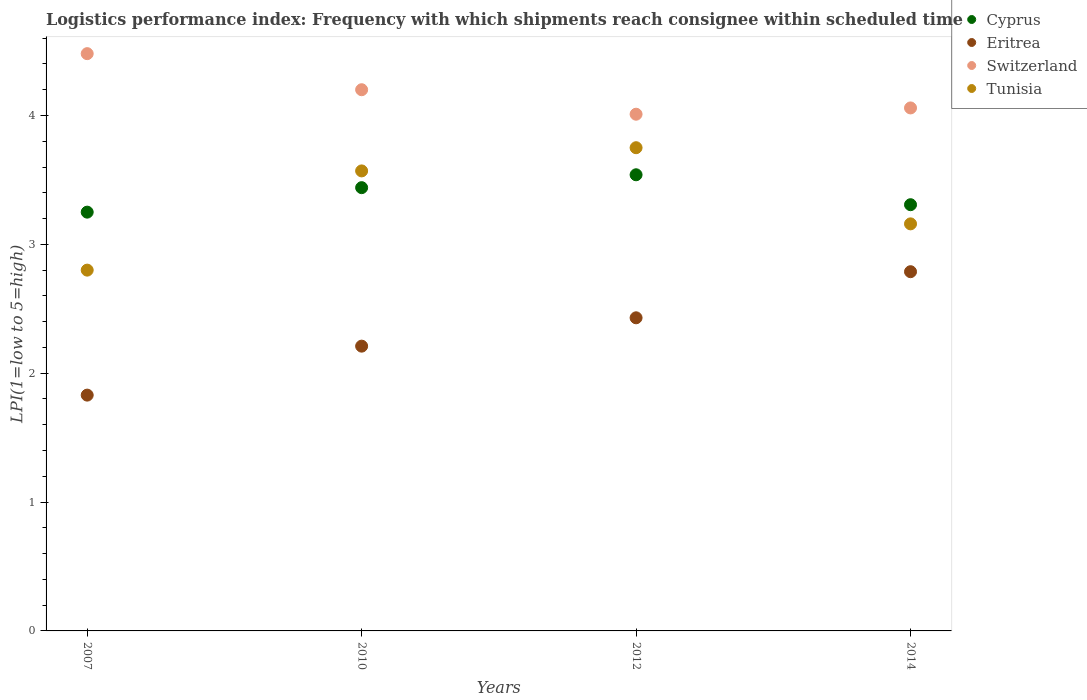How many different coloured dotlines are there?
Provide a short and direct response. 4. Is the number of dotlines equal to the number of legend labels?
Keep it short and to the point. Yes. What is the logistics performance index in Cyprus in 2012?
Your answer should be very brief. 3.54. Across all years, what is the maximum logistics performance index in Cyprus?
Make the answer very short. 3.54. Across all years, what is the minimum logistics performance index in Cyprus?
Ensure brevity in your answer.  3.25. What is the total logistics performance index in Cyprus in the graph?
Your answer should be compact. 13.54. What is the difference between the logistics performance index in Cyprus in 2012 and that in 2014?
Provide a short and direct response. 0.23. What is the difference between the logistics performance index in Cyprus in 2012 and the logistics performance index in Tunisia in 2007?
Your answer should be compact. 0.74. What is the average logistics performance index in Cyprus per year?
Your answer should be compact. 3.38. In the year 2014, what is the difference between the logistics performance index in Switzerland and logistics performance index in Eritrea?
Give a very brief answer. 1.27. What is the ratio of the logistics performance index in Tunisia in 2010 to that in 2014?
Offer a very short reply. 1.13. What is the difference between the highest and the second highest logistics performance index in Cyprus?
Offer a terse response. 0.1. What is the difference between the highest and the lowest logistics performance index in Cyprus?
Your answer should be very brief. 0.29. In how many years, is the logistics performance index in Tunisia greater than the average logistics performance index in Tunisia taken over all years?
Offer a very short reply. 2. Is the sum of the logistics performance index in Cyprus in 2007 and 2012 greater than the maximum logistics performance index in Eritrea across all years?
Your answer should be compact. Yes. Is it the case that in every year, the sum of the logistics performance index in Switzerland and logistics performance index in Tunisia  is greater than the sum of logistics performance index in Eritrea and logistics performance index in Cyprus?
Ensure brevity in your answer.  Yes. How many years are there in the graph?
Offer a terse response. 4. What is the difference between two consecutive major ticks on the Y-axis?
Your answer should be very brief. 1. Does the graph contain any zero values?
Make the answer very short. No. How many legend labels are there?
Provide a succinct answer. 4. What is the title of the graph?
Your answer should be compact. Logistics performance index: Frequency with which shipments reach consignee within scheduled time. Does "Low & middle income" appear as one of the legend labels in the graph?
Your response must be concise. No. What is the label or title of the X-axis?
Keep it short and to the point. Years. What is the label or title of the Y-axis?
Offer a terse response. LPI(1=low to 5=high). What is the LPI(1=low to 5=high) in Eritrea in 2007?
Offer a terse response. 1.83. What is the LPI(1=low to 5=high) of Switzerland in 2007?
Provide a succinct answer. 4.48. What is the LPI(1=low to 5=high) in Cyprus in 2010?
Your response must be concise. 3.44. What is the LPI(1=low to 5=high) of Eritrea in 2010?
Give a very brief answer. 2.21. What is the LPI(1=low to 5=high) of Switzerland in 2010?
Your answer should be very brief. 4.2. What is the LPI(1=low to 5=high) of Tunisia in 2010?
Your answer should be very brief. 3.57. What is the LPI(1=low to 5=high) in Cyprus in 2012?
Make the answer very short. 3.54. What is the LPI(1=low to 5=high) in Eritrea in 2012?
Your response must be concise. 2.43. What is the LPI(1=low to 5=high) in Switzerland in 2012?
Provide a succinct answer. 4.01. What is the LPI(1=low to 5=high) of Tunisia in 2012?
Give a very brief answer. 3.75. What is the LPI(1=low to 5=high) in Cyprus in 2014?
Offer a very short reply. 3.31. What is the LPI(1=low to 5=high) of Eritrea in 2014?
Make the answer very short. 2.79. What is the LPI(1=low to 5=high) of Switzerland in 2014?
Offer a terse response. 4.06. What is the LPI(1=low to 5=high) of Tunisia in 2014?
Offer a terse response. 3.16. Across all years, what is the maximum LPI(1=low to 5=high) in Cyprus?
Your response must be concise. 3.54. Across all years, what is the maximum LPI(1=low to 5=high) of Eritrea?
Your response must be concise. 2.79. Across all years, what is the maximum LPI(1=low to 5=high) in Switzerland?
Ensure brevity in your answer.  4.48. Across all years, what is the maximum LPI(1=low to 5=high) in Tunisia?
Your answer should be very brief. 3.75. Across all years, what is the minimum LPI(1=low to 5=high) of Eritrea?
Your response must be concise. 1.83. Across all years, what is the minimum LPI(1=low to 5=high) of Switzerland?
Your answer should be very brief. 4.01. Across all years, what is the minimum LPI(1=low to 5=high) of Tunisia?
Your answer should be compact. 2.8. What is the total LPI(1=low to 5=high) of Cyprus in the graph?
Your response must be concise. 13.54. What is the total LPI(1=low to 5=high) of Eritrea in the graph?
Your answer should be very brief. 9.26. What is the total LPI(1=low to 5=high) in Switzerland in the graph?
Your answer should be very brief. 16.75. What is the total LPI(1=low to 5=high) of Tunisia in the graph?
Give a very brief answer. 13.28. What is the difference between the LPI(1=low to 5=high) of Cyprus in 2007 and that in 2010?
Your answer should be very brief. -0.19. What is the difference between the LPI(1=low to 5=high) in Eritrea in 2007 and that in 2010?
Offer a very short reply. -0.38. What is the difference between the LPI(1=low to 5=high) in Switzerland in 2007 and that in 2010?
Provide a succinct answer. 0.28. What is the difference between the LPI(1=low to 5=high) of Tunisia in 2007 and that in 2010?
Provide a short and direct response. -0.77. What is the difference between the LPI(1=low to 5=high) of Cyprus in 2007 and that in 2012?
Give a very brief answer. -0.29. What is the difference between the LPI(1=low to 5=high) in Eritrea in 2007 and that in 2012?
Your response must be concise. -0.6. What is the difference between the LPI(1=low to 5=high) of Switzerland in 2007 and that in 2012?
Make the answer very short. 0.47. What is the difference between the LPI(1=low to 5=high) of Tunisia in 2007 and that in 2012?
Your answer should be very brief. -0.95. What is the difference between the LPI(1=low to 5=high) in Cyprus in 2007 and that in 2014?
Keep it short and to the point. -0.06. What is the difference between the LPI(1=low to 5=high) in Eritrea in 2007 and that in 2014?
Give a very brief answer. -0.96. What is the difference between the LPI(1=low to 5=high) in Switzerland in 2007 and that in 2014?
Provide a short and direct response. 0.42. What is the difference between the LPI(1=low to 5=high) of Tunisia in 2007 and that in 2014?
Your answer should be very brief. -0.36. What is the difference between the LPI(1=low to 5=high) in Eritrea in 2010 and that in 2012?
Your answer should be very brief. -0.22. What is the difference between the LPI(1=low to 5=high) of Switzerland in 2010 and that in 2012?
Your answer should be very brief. 0.19. What is the difference between the LPI(1=low to 5=high) of Tunisia in 2010 and that in 2012?
Offer a very short reply. -0.18. What is the difference between the LPI(1=low to 5=high) of Cyprus in 2010 and that in 2014?
Provide a succinct answer. 0.13. What is the difference between the LPI(1=low to 5=high) in Eritrea in 2010 and that in 2014?
Ensure brevity in your answer.  -0.58. What is the difference between the LPI(1=low to 5=high) in Switzerland in 2010 and that in 2014?
Provide a succinct answer. 0.14. What is the difference between the LPI(1=low to 5=high) in Tunisia in 2010 and that in 2014?
Your answer should be very brief. 0.41. What is the difference between the LPI(1=low to 5=high) in Cyprus in 2012 and that in 2014?
Ensure brevity in your answer.  0.23. What is the difference between the LPI(1=low to 5=high) of Eritrea in 2012 and that in 2014?
Offer a terse response. -0.36. What is the difference between the LPI(1=low to 5=high) of Switzerland in 2012 and that in 2014?
Give a very brief answer. -0.05. What is the difference between the LPI(1=low to 5=high) of Tunisia in 2012 and that in 2014?
Provide a succinct answer. 0.59. What is the difference between the LPI(1=low to 5=high) in Cyprus in 2007 and the LPI(1=low to 5=high) in Eritrea in 2010?
Keep it short and to the point. 1.04. What is the difference between the LPI(1=low to 5=high) of Cyprus in 2007 and the LPI(1=low to 5=high) of Switzerland in 2010?
Keep it short and to the point. -0.95. What is the difference between the LPI(1=low to 5=high) in Cyprus in 2007 and the LPI(1=low to 5=high) in Tunisia in 2010?
Offer a very short reply. -0.32. What is the difference between the LPI(1=low to 5=high) in Eritrea in 2007 and the LPI(1=low to 5=high) in Switzerland in 2010?
Offer a terse response. -2.37. What is the difference between the LPI(1=low to 5=high) in Eritrea in 2007 and the LPI(1=low to 5=high) in Tunisia in 2010?
Your answer should be compact. -1.74. What is the difference between the LPI(1=low to 5=high) of Switzerland in 2007 and the LPI(1=low to 5=high) of Tunisia in 2010?
Offer a very short reply. 0.91. What is the difference between the LPI(1=low to 5=high) of Cyprus in 2007 and the LPI(1=low to 5=high) of Eritrea in 2012?
Offer a terse response. 0.82. What is the difference between the LPI(1=low to 5=high) of Cyprus in 2007 and the LPI(1=low to 5=high) of Switzerland in 2012?
Offer a very short reply. -0.76. What is the difference between the LPI(1=low to 5=high) in Cyprus in 2007 and the LPI(1=low to 5=high) in Tunisia in 2012?
Provide a succinct answer. -0.5. What is the difference between the LPI(1=low to 5=high) in Eritrea in 2007 and the LPI(1=low to 5=high) in Switzerland in 2012?
Give a very brief answer. -2.18. What is the difference between the LPI(1=low to 5=high) of Eritrea in 2007 and the LPI(1=low to 5=high) of Tunisia in 2012?
Ensure brevity in your answer.  -1.92. What is the difference between the LPI(1=low to 5=high) in Switzerland in 2007 and the LPI(1=low to 5=high) in Tunisia in 2012?
Your answer should be compact. 0.73. What is the difference between the LPI(1=low to 5=high) of Cyprus in 2007 and the LPI(1=low to 5=high) of Eritrea in 2014?
Offer a terse response. 0.46. What is the difference between the LPI(1=low to 5=high) in Cyprus in 2007 and the LPI(1=low to 5=high) in Switzerland in 2014?
Make the answer very short. -0.81. What is the difference between the LPI(1=low to 5=high) of Cyprus in 2007 and the LPI(1=low to 5=high) of Tunisia in 2014?
Your response must be concise. 0.09. What is the difference between the LPI(1=low to 5=high) in Eritrea in 2007 and the LPI(1=low to 5=high) in Switzerland in 2014?
Your answer should be very brief. -2.23. What is the difference between the LPI(1=low to 5=high) in Eritrea in 2007 and the LPI(1=low to 5=high) in Tunisia in 2014?
Provide a short and direct response. -1.33. What is the difference between the LPI(1=low to 5=high) of Switzerland in 2007 and the LPI(1=low to 5=high) of Tunisia in 2014?
Offer a very short reply. 1.32. What is the difference between the LPI(1=low to 5=high) of Cyprus in 2010 and the LPI(1=low to 5=high) of Switzerland in 2012?
Provide a succinct answer. -0.57. What is the difference between the LPI(1=low to 5=high) of Cyprus in 2010 and the LPI(1=low to 5=high) of Tunisia in 2012?
Provide a short and direct response. -0.31. What is the difference between the LPI(1=low to 5=high) in Eritrea in 2010 and the LPI(1=low to 5=high) in Tunisia in 2012?
Offer a terse response. -1.54. What is the difference between the LPI(1=low to 5=high) of Switzerland in 2010 and the LPI(1=low to 5=high) of Tunisia in 2012?
Provide a short and direct response. 0.45. What is the difference between the LPI(1=low to 5=high) in Cyprus in 2010 and the LPI(1=low to 5=high) in Eritrea in 2014?
Provide a succinct answer. 0.65. What is the difference between the LPI(1=low to 5=high) of Cyprus in 2010 and the LPI(1=low to 5=high) of Switzerland in 2014?
Your response must be concise. -0.62. What is the difference between the LPI(1=low to 5=high) in Cyprus in 2010 and the LPI(1=low to 5=high) in Tunisia in 2014?
Make the answer very short. 0.28. What is the difference between the LPI(1=low to 5=high) of Eritrea in 2010 and the LPI(1=low to 5=high) of Switzerland in 2014?
Your response must be concise. -1.85. What is the difference between the LPI(1=low to 5=high) in Eritrea in 2010 and the LPI(1=low to 5=high) in Tunisia in 2014?
Your answer should be compact. -0.95. What is the difference between the LPI(1=low to 5=high) in Switzerland in 2010 and the LPI(1=low to 5=high) in Tunisia in 2014?
Provide a short and direct response. 1.04. What is the difference between the LPI(1=low to 5=high) in Cyprus in 2012 and the LPI(1=low to 5=high) in Eritrea in 2014?
Give a very brief answer. 0.75. What is the difference between the LPI(1=low to 5=high) in Cyprus in 2012 and the LPI(1=low to 5=high) in Switzerland in 2014?
Provide a short and direct response. -0.52. What is the difference between the LPI(1=low to 5=high) in Cyprus in 2012 and the LPI(1=low to 5=high) in Tunisia in 2014?
Provide a short and direct response. 0.38. What is the difference between the LPI(1=low to 5=high) of Eritrea in 2012 and the LPI(1=low to 5=high) of Switzerland in 2014?
Ensure brevity in your answer.  -1.63. What is the difference between the LPI(1=low to 5=high) in Eritrea in 2012 and the LPI(1=low to 5=high) in Tunisia in 2014?
Give a very brief answer. -0.73. What is the difference between the LPI(1=low to 5=high) in Switzerland in 2012 and the LPI(1=low to 5=high) in Tunisia in 2014?
Provide a succinct answer. 0.85. What is the average LPI(1=low to 5=high) of Cyprus per year?
Your response must be concise. 3.38. What is the average LPI(1=low to 5=high) in Eritrea per year?
Provide a succinct answer. 2.31. What is the average LPI(1=low to 5=high) in Switzerland per year?
Ensure brevity in your answer.  4.19. What is the average LPI(1=low to 5=high) of Tunisia per year?
Ensure brevity in your answer.  3.32. In the year 2007, what is the difference between the LPI(1=low to 5=high) in Cyprus and LPI(1=low to 5=high) in Eritrea?
Your response must be concise. 1.42. In the year 2007, what is the difference between the LPI(1=low to 5=high) of Cyprus and LPI(1=low to 5=high) of Switzerland?
Provide a short and direct response. -1.23. In the year 2007, what is the difference between the LPI(1=low to 5=high) of Cyprus and LPI(1=low to 5=high) of Tunisia?
Provide a short and direct response. 0.45. In the year 2007, what is the difference between the LPI(1=low to 5=high) of Eritrea and LPI(1=low to 5=high) of Switzerland?
Offer a terse response. -2.65. In the year 2007, what is the difference between the LPI(1=low to 5=high) in Eritrea and LPI(1=low to 5=high) in Tunisia?
Your answer should be very brief. -0.97. In the year 2007, what is the difference between the LPI(1=low to 5=high) in Switzerland and LPI(1=low to 5=high) in Tunisia?
Your answer should be very brief. 1.68. In the year 2010, what is the difference between the LPI(1=low to 5=high) in Cyprus and LPI(1=low to 5=high) in Eritrea?
Offer a very short reply. 1.23. In the year 2010, what is the difference between the LPI(1=low to 5=high) in Cyprus and LPI(1=low to 5=high) in Switzerland?
Offer a very short reply. -0.76. In the year 2010, what is the difference between the LPI(1=low to 5=high) of Cyprus and LPI(1=low to 5=high) of Tunisia?
Give a very brief answer. -0.13. In the year 2010, what is the difference between the LPI(1=low to 5=high) of Eritrea and LPI(1=low to 5=high) of Switzerland?
Make the answer very short. -1.99. In the year 2010, what is the difference between the LPI(1=low to 5=high) of Eritrea and LPI(1=low to 5=high) of Tunisia?
Provide a short and direct response. -1.36. In the year 2010, what is the difference between the LPI(1=low to 5=high) in Switzerland and LPI(1=low to 5=high) in Tunisia?
Your response must be concise. 0.63. In the year 2012, what is the difference between the LPI(1=low to 5=high) of Cyprus and LPI(1=low to 5=high) of Eritrea?
Your answer should be very brief. 1.11. In the year 2012, what is the difference between the LPI(1=low to 5=high) of Cyprus and LPI(1=low to 5=high) of Switzerland?
Your response must be concise. -0.47. In the year 2012, what is the difference between the LPI(1=low to 5=high) in Cyprus and LPI(1=low to 5=high) in Tunisia?
Keep it short and to the point. -0.21. In the year 2012, what is the difference between the LPI(1=low to 5=high) in Eritrea and LPI(1=low to 5=high) in Switzerland?
Give a very brief answer. -1.58. In the year 2012, what is the difference between the LPI(1=low to 5=high) of Eritrea and LPI(1=low to 5=high) of Tunisia?
Keep it short and to the point. -1.32. In the year 2012, what is the difference between the LPI(1=low to 5=high) of Switzerland and LPI(1=low to 5=high) of Tunisia?
Offer a very short reply. 0.26. In the year 2014, what is the difference between the LPI(1=low to 5=high) of Cyprus and LPI(1=low to 5=high) of Eritrea?
Keep it short and to the point. 0.52. In the year 2014, what is the difference between the LPI(1=low to 5=high) in Cyprus and LPI(1=low to 5=high) in Switzerland?
Ensure brevity in your answer.  -0.75. In the year 2014, what is the difference between the LPI(1=low to 5=high) of Cyprus and LPI(1=low to 5=high) of Tunisia?
Make the answer very short. 0.15. In the year 2014, what is the difference between the LPI(1=low to 5=high) of Eritrea and LPI(1=low to 5=high) of Switzerland?
Give a very brief answer. -1.27. In the year 2014, what is the difference between the LPI(1=low to 5=high) in Eritrea and LPI(1=low to 5=high) in Tunisia?
Your answer should be compact. -0.37. In the year 2014, what is the difference between the LPI(1=low to 5=high) in Switzerland and LPI(1=low to 5=high) in Tunisia?
Give a very brief answer. 0.9. What is the ratio of the LPI(1=low to 5=high) of Cyprus in 2007 to that in 2010?
Provide a succinct answer. 0.94. What is the ratio of the LPI(1=low to 5=high) of Eritrea in 2007 to that in 2010?
Your answer should be very brief. 0.83. What is the ratio of the LPI(1=low to 5=high) of Switzerland in 2007 to that in 2010?
Keep it short and to the point. 1.07. What is the ratio of the LPI(1=low to 5=high) in Tunisia in 2007 to that in 2010?
Offer a terse response. 0.78. What is the ratio of the LPI(1=low to 5=high) in Cyprus in 2007 to that in 2012?
Provide a short and direct response. 0.92. What is the ratio of the LPI(1=low to 5=high) in Eritrea in 2007 to that in 2012?
Your response must be concise. 0.75. What is the ratio of the LPI(1=low to 5=high) of Switzerland in 2007 to that in 2012?
Offer a terse response. 1.12. What is the ratio of the LPI(1=low to 5=high) in Tunisia in 2007 to that in 2012?
Provide a short and direct response. 0.75. What is the ratio of the LPI(1=low to 5=high) in Cyprus in 2007 to that in 2014?
Ensure brevity in your answer.  0.98. What is the ratio of the LPI(1=low to 5=high) in Eritrea in 2007 to that in 2014?
Your response must be concise. 0.66. What is the ratio of the LPI(1=low to 5=high) of Switzerland in 2007 to that in 2014?
Make the answer very short. 1.1. What is the ratio of the LPI(1=low to 5=high) in Tunisia in 2007 to that in 2014?
Keep it short and to the point. 0.89. What is the ratio of the LPI(1=low to 5=high) in Cyprus in 2010 to that in 2012?
Your answer should be very brief. 0.97. What is the ratio of the LPI(1=low to 5=high) in Eritrea in 2010 to that in 2012?
Provide a short and direct response. 0.91. What is the ratio of the LPI(1=low to 5=high) in Switzerland in 2010 to that in 2012?
Your answer should be very brief. 1.05. What is the ratio of the LPI(1=low to 5=high) in Cyprus in 2010 to that in 2014?
Offer a very short reply. 1.04. What is the ratio of the LPI(1=low to 5=high) of Eritrea in 2010 to that in 2014?
Provide a short and direct response. 0.79. What is the ratio of the LPI(1=low to 5=high) of Switzerland in 2010 to that in 2014?
Provide a short and direct response. 1.03. What is the ratio of the LPI(1=low to 5=high) of Tunisia in 2010 to that in 2014?
Offer a terse response. 1.13. What is the ratio of the LPI(1=low to 5=high) in Cyprus in 2012 to that in 2014?
Make the answer very short. 1.07. What is the ratio of the LPI(1=low to 5=high) in Eritrea in 2012 to that in 2014?
Give a very brief answer. 0.87. What is the ratio of the LPI(1=low to 5=high) of Tunisia in 2012 to that in 2014?
Offer a very short reply. 1.19. What is the difference between the highest and the second highest LPI(1=low to 5=high) in Cyprus?
Offer a very short reply. 0.1. What is the difference between the highest and the second highest LPI(1=low to 5=high) of Eritrea?
Your response must be concise. 0.36. What is the difference between the highest and the second highest LPI(1=low to 5=high) of Switzerland?
Provide a succinct answer. 0.28. What is the difference between the highest and the second highest LPI(1=low to 5=high) of Tunisia?
Your answer should be compact. 0.18. What is the difference between the highest and the lowest LPI(1=low to 5=high) in Cyprus?
Ensure brevity in your answer.  0.29. What is the difference between the highest and the lowest LPI(1=low to 5=high) of Eritrea?
Your answer should be very brief. 0.96. What is the difference between the highest and the lowest LPI(1=low to 5=high) of Switzerland?
Give a very brief answer. 0.47. 